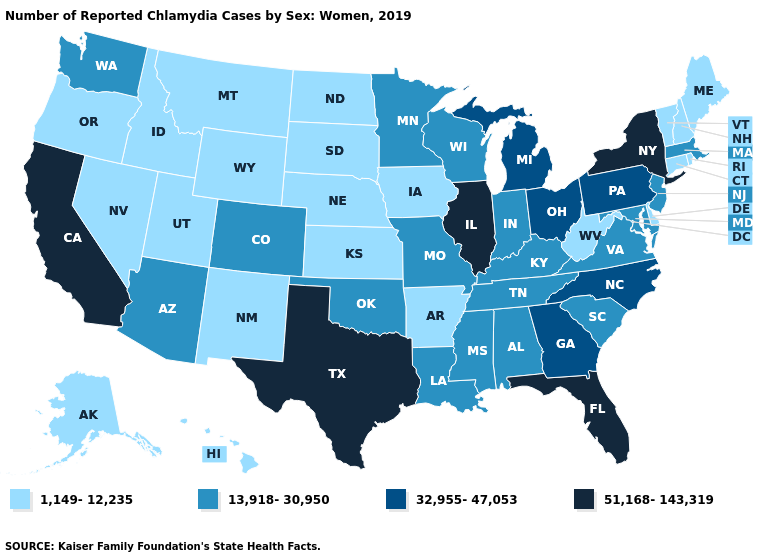Name the states that have a value in the range 32,955-47,053?
Short answer required. Georgia, Michigan, North Carolina, Ohio, Pennsylvania. Does the map have missing data?
Answer briefly. No. What is the value of Ohio?
Keep it brief. 32,955-47,053. Is the legend a continuous bar?
Give a very brief answer. No. What is the lowest value in the USA?
Be succinct. 1,149-12,235. Name the states that have a value in the range 1,149-12,235?
Quick response, please. Alaska, Arkansas, Connecticut, Delaware, Hawaii, Idaho, Iowa, Kansas, Maine, Montana, Nebraska, Nevada, New Hampshire, New Mexico, North Dakota, Oregon, Rhode Island, South Dakota, Utah, Vermont, West Virginia, Wyoming. Among the states that border New York , does Connecticut have the lowest value?
Quick response, please. Yes. Name the states that have a value in the range 51,168-143,319?
Concise answer only. California, Florida, Illinois, New York, Texas. Does Virginia have the lowest value in the USA?
Short answer required. No. What is the value of North Carolina?
Concise answer only. 32,955-47,053. Among the states that border Massachusetts , which have the lowest value?
Answer briefly. Connecticut, New Hampshire, Rhode Island, Vermont. What is the highest value in the West ?
Short answer required. 51,168-143,319. How many symbols are there in the legend?
Answer briefly. 4. Name the states that have a value in the range 13,918-30,950?
Quick response, please. Alabama, Arizona, Colorado, Indiana, Kentucky, Louisiana, Maryland, Massachusetts, Minnesota, Mississippi, Missouri, New Jersey, Oklahoma, South Carolina, Tennessee, Virginia, Washington, Wisconsin. Does Arkansas have the same value as Maine?
Give a very brief answer. Yes. 